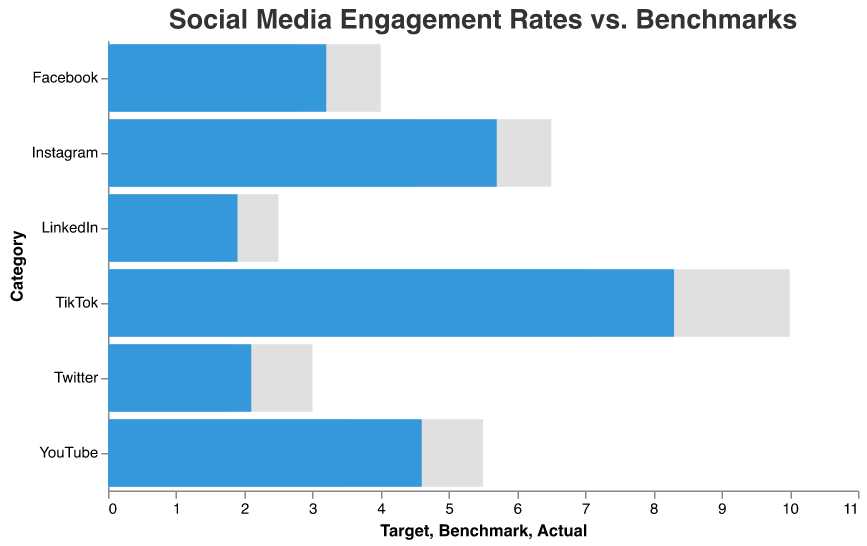What's the title of the chart? The title is prominently displayed at the top of the chart and reads "Social Media Engagement Rates vs. Benchmarks".
Answer: Social Media Engagement Rates vs. Benchmarks Which social media platform has the highest actual engagement rate? By examining the chart, we see that TikTok has the longest blue bar for the actual engagement rate at 8.3.
Answer: TikTok What is the engagement rate benchmark for YouTube? The grey bar indicates benchmarks, and for YouTube, it reaches 3.5 on the x-axis, identifying it as the benchmark value.
Answer: 3.5 Which platform's actual engagement rate is closest to its benchmark? Comparing each platform's actual engagement (blue bar) to the benchmark (grey bar), LinkedIn has an actual rate of 1.9 and a benchmark of 1.5, indicating the smallest difference of 0.4.
Answer: LinkedIn How many platforms have actual engagement rates above their benchmarks? By evaluating each comparison where the blue bar is longer than the grey bar, we see Facebook, Instagram, Twitter, LinkedIn, TikTok, and YouTube all exceed their benchmarks. This counts to 6 platforms.
Answer: 6 What is the difference between the actual and target engagement rates for Instagram? The actual engagement rate for Instagram is 5.7, and the target is 6.5. The difference can be calculated by subtracting the actual from the target: 6.5 - 5.7 = 0.8.
Answer: 0.8 Which platforms have actual engagement rates lower than their targets? For this, we compare the blue bars (actual) and the grey bars (target). For Facebook, Instagram, Twitter, LinkedIn, and YouTube, the actual rates are less than their targets. TikTok is the only exception.
Answer: Facebook, Instagram, Twitter, LinkedIn, YouTube What's the difference between the highest and lowest actual engagement rates? The highest actual engagement rate is TikTok's 8.3, and the lowest is LinkedIn's 1.9. The difference is 8.3 - 1.9 = 6.4.
Answer: 6.4 Which platform's actual engagement rate exceeds the benchmark by the largest margin? Calculating the differences between the actual (blue) and benchmark (grey) rates for each platform, TikTok shows the highest margin: 8.3 (actual) - 7.0 (benchmark) = 1.3.
Answer: TikTok Do any platforms meet or exceed their target engagement rates? Comparing the actual engagement rates (blue bars) with the target rates (grey bars), no platform meets or exceeds its target engagement rate.
Answer: No 